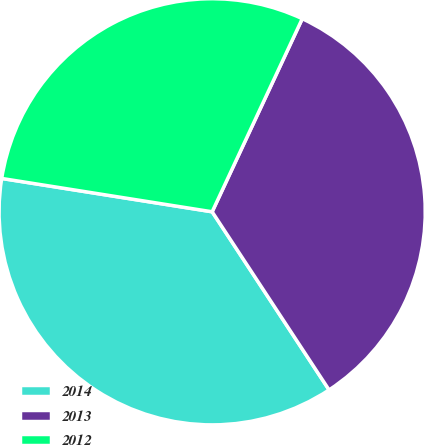Convert chart to OTSL. <chart><loc_0><loc_0><loc_500><loc_500><pie_chart><fcel>2014<fcel>2013<fcel>2012<nl><fcel>36.75%<fcel>33.81%<fcel>29.45%<nl></chart> 